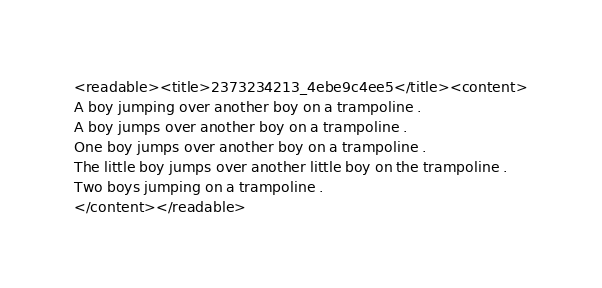Convert code to text. <code><loc_0><loc_0><loc_500><loc_500><_XML_><readable><title>2373234213_4ebe9c4ee5</title><content>
A boy jumping over another boy on a trampoline .
A boy jumps over another boy on a trampoline .
One boy jumps over another boy on a trampoline .
The little boy jumps over another little boy on the trampoline .
Two boys jumping on a trampoline .
</content></readable></code> 